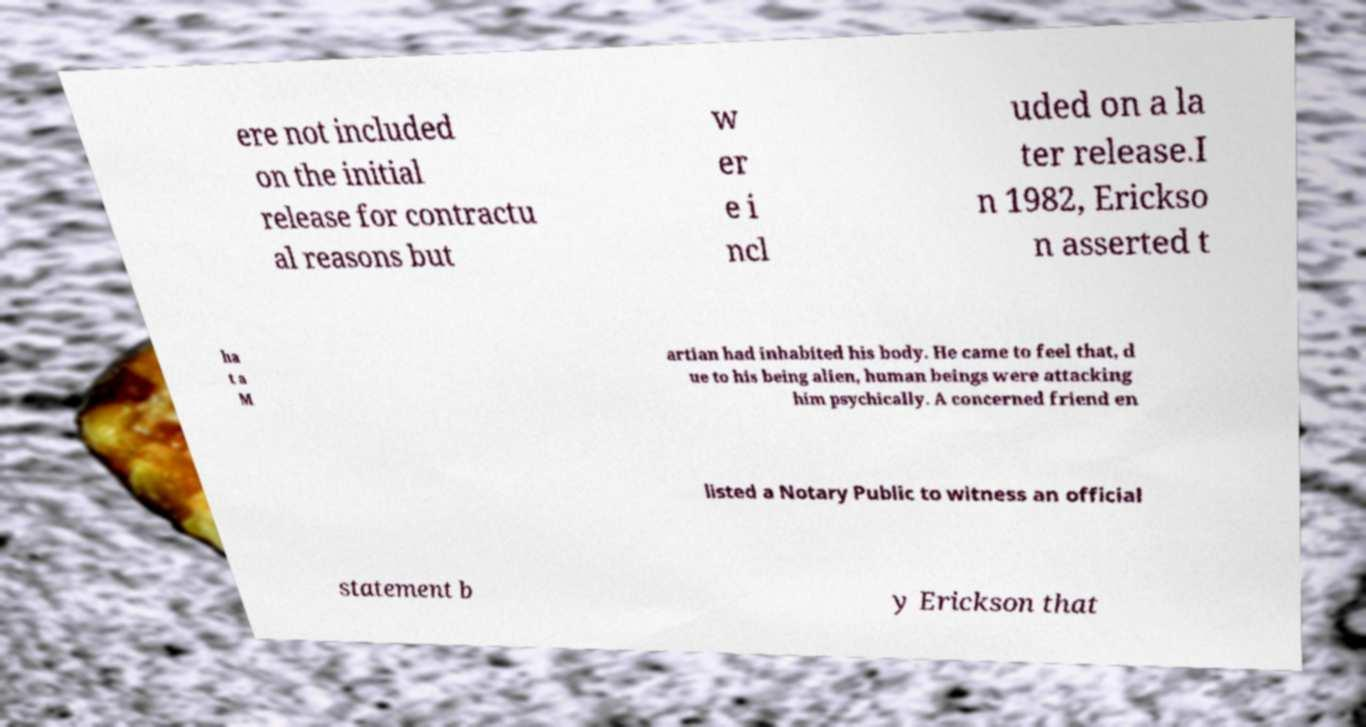What messages or text are displayed in this image? I need them in a readable, typed format. ere not included on the initial release for contractu al reasons but w er e i ncl uded on a la ter release.I n 1982, Erickso n asserted t ha t a M artian had inhabited his body. He came to feel that, d ue to his being alien, human beings were attacking him psychically. A concerned friend en listed a Notary Public to witness an official statement b y Erickson that 